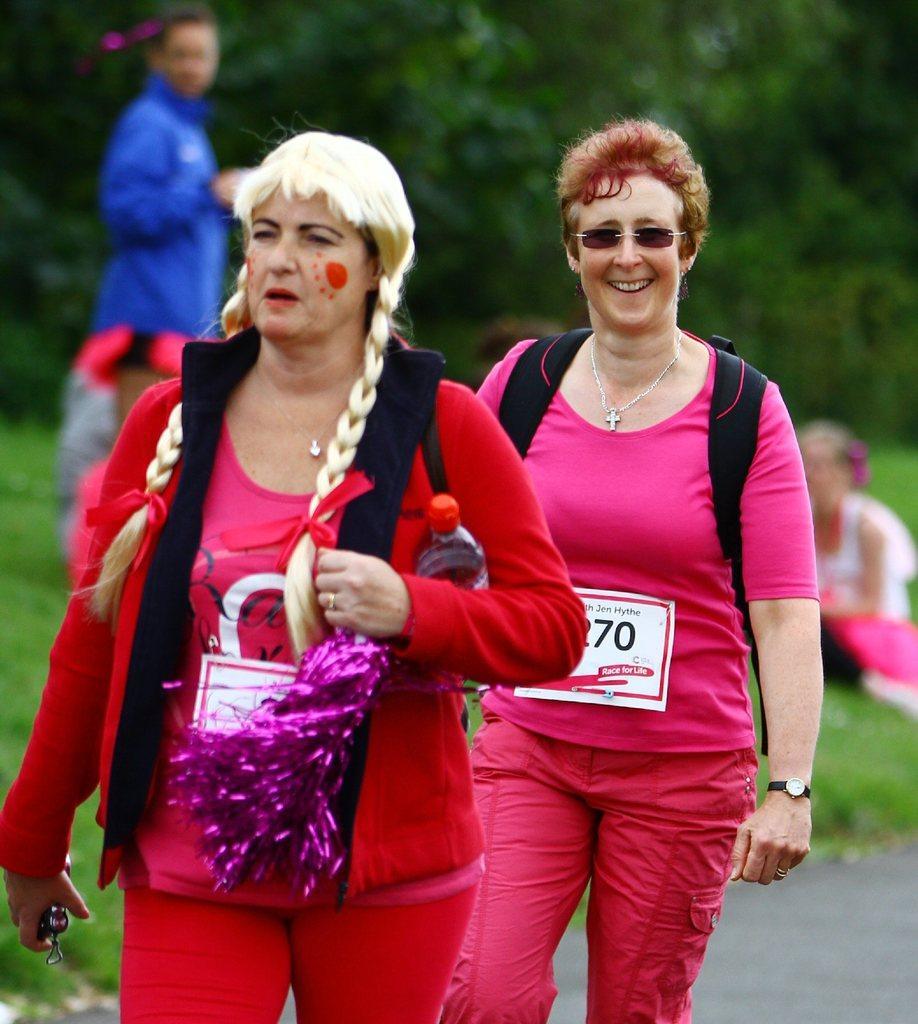Can you describe this image briefly? In this image we can see two women. One woman is wearing pink color dress and carrying bag. The other woman is wearing a red color dress, carrying bag and holding objects in her hands. In the background, we can see people, grassy land and trees. 